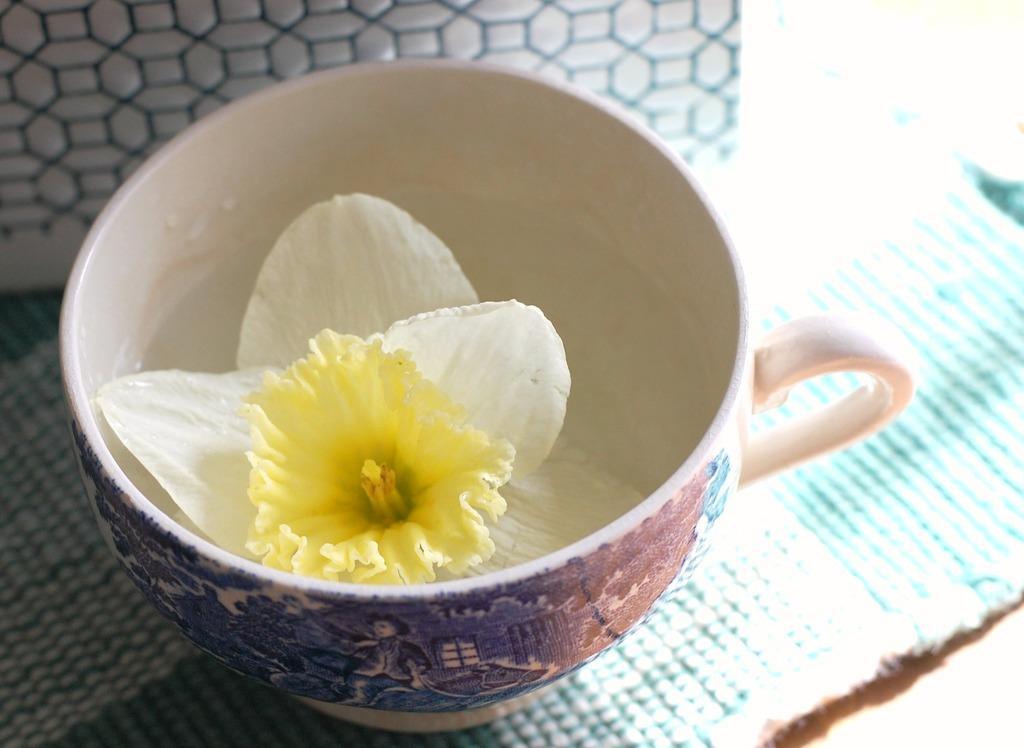What object is in the image that can hold liquid? There is a cup in the image. What is inside the cup? A flower is present in the cup. What can be seen on the flower in the image? Pollen grains are visible in the image. Is there a basketball game happening in the image? No, there is no basketball game or any reference to sports in the image. 